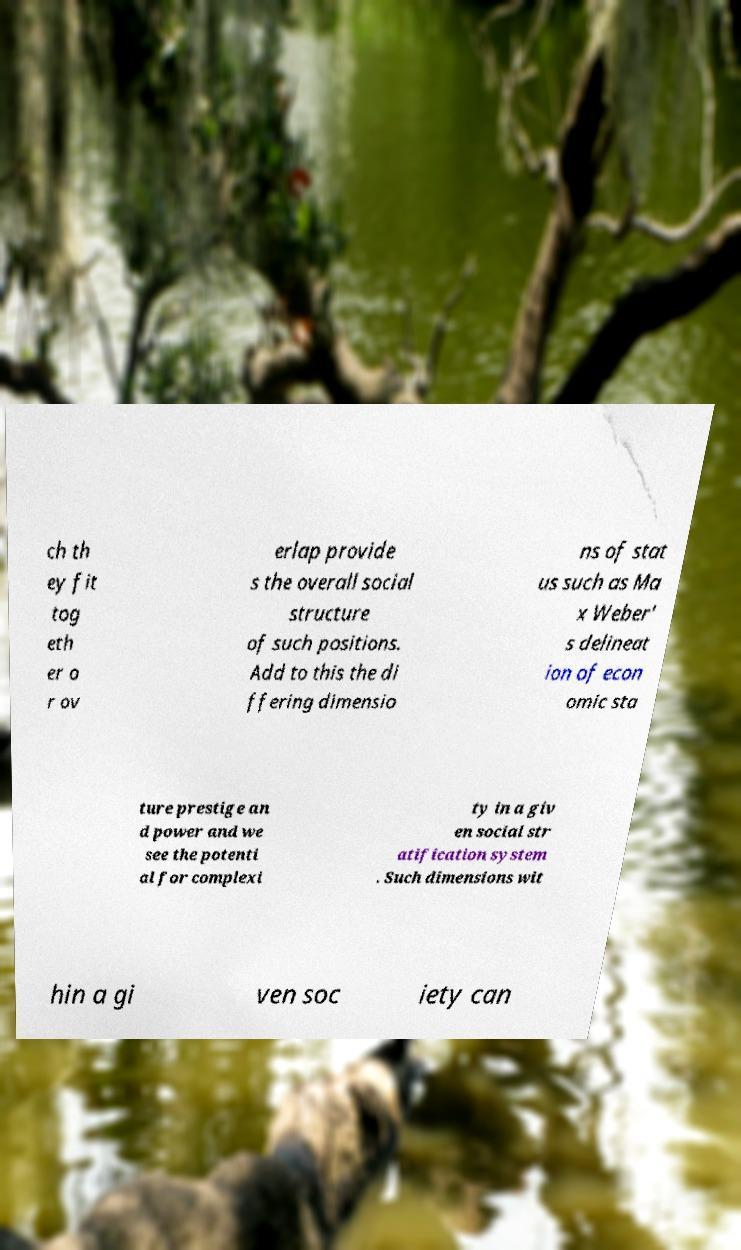Please identify and transcribe the text found in this image. ch th ey fit tog eth er o r ov erlap provide s the overall social structure of such positions. Add to this the di ffering dimensio ns of stat us such as Ma x Weber' s delineat ion of econ omic sta ture prestige an d power and we see the potenti al for complexi ty in a giv en social str atification system . Such dimensions wit hin a gi ven soc iety can 